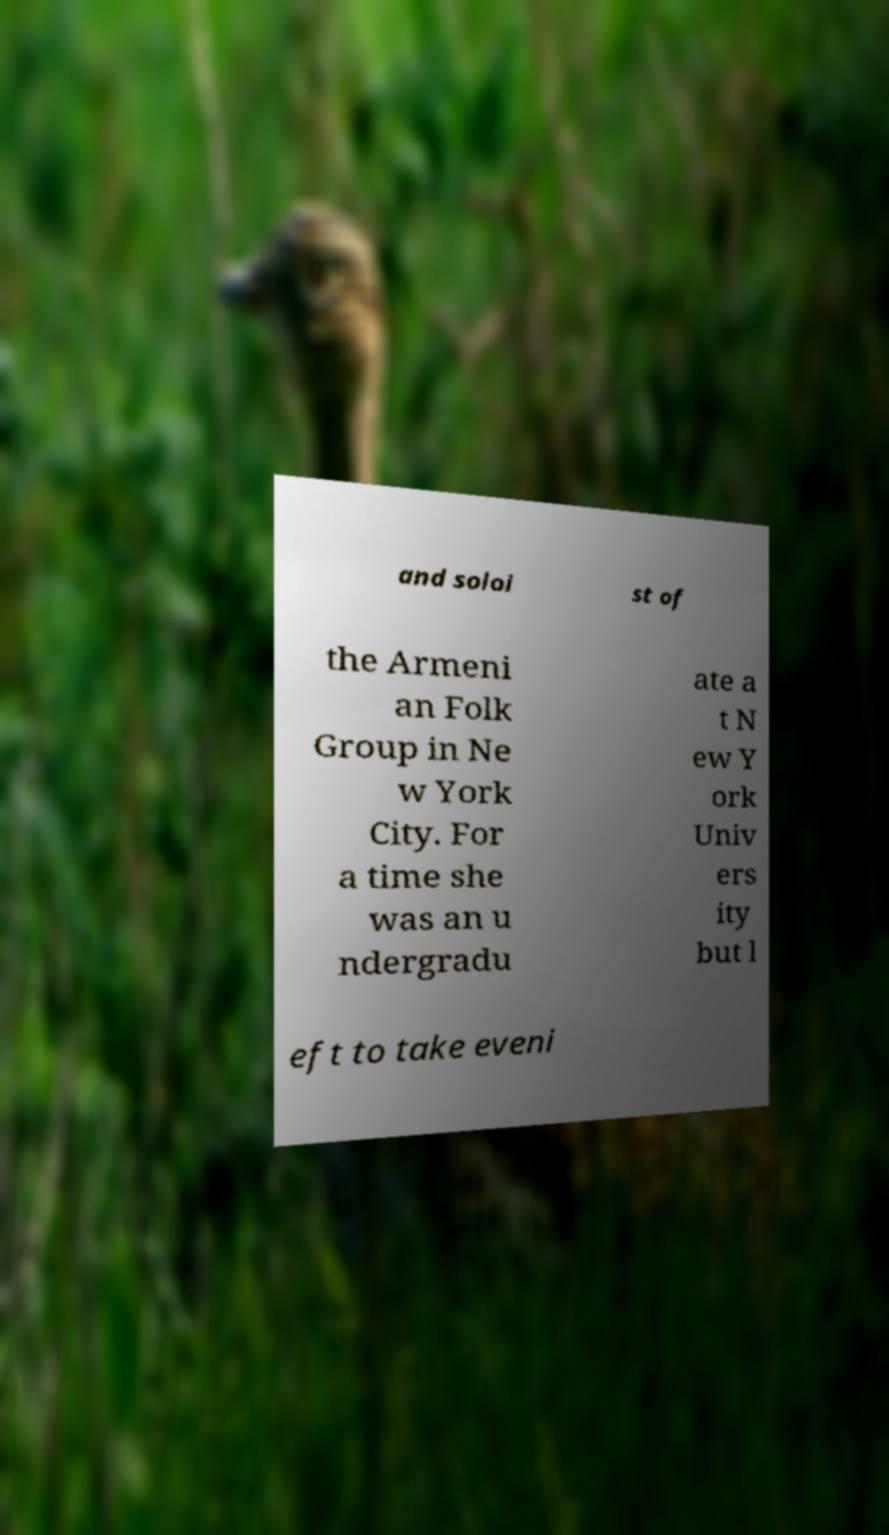Please read and relay the text visible in this image. What does it say? and soloi st of the Armeni an Folk Group in Ne w York City. For a time she was an u ndergradu ate a t N ew Y ork Univ ers ity but l eft to take eveni 